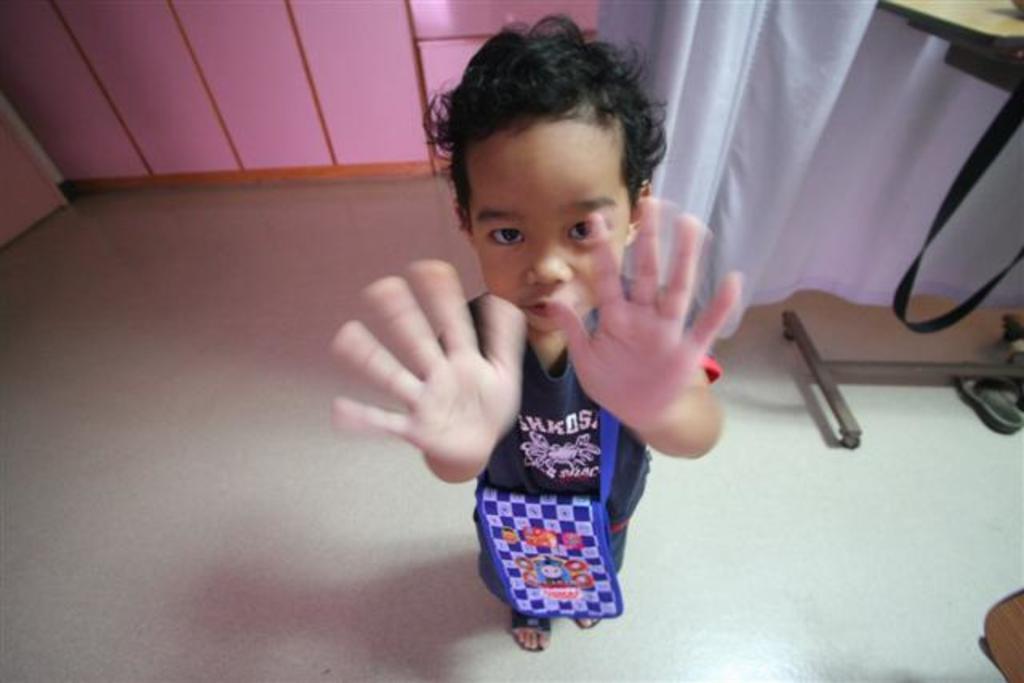Describe this image in one or two sentences. In this picture I can see a kid in the middle, on the right side it looks like a curtain. 